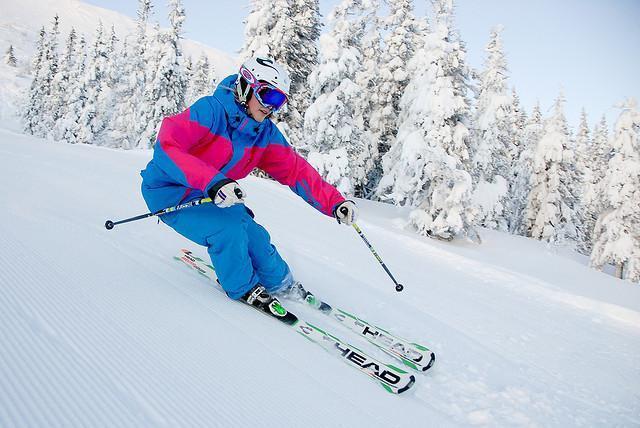How many umbrellas are there?
Give a very brief answer. 0. 